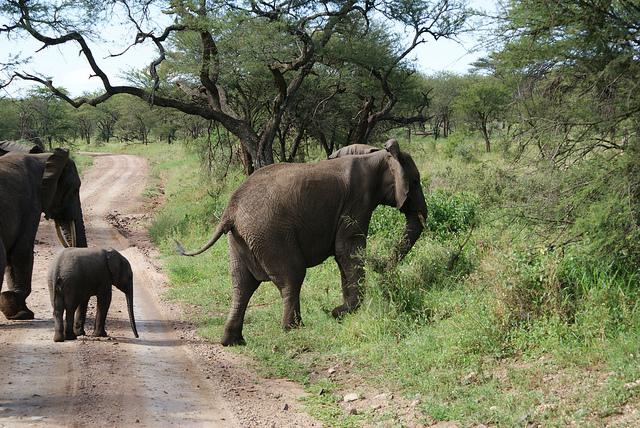How many elephants are standing right on the dirt road to the left? two 